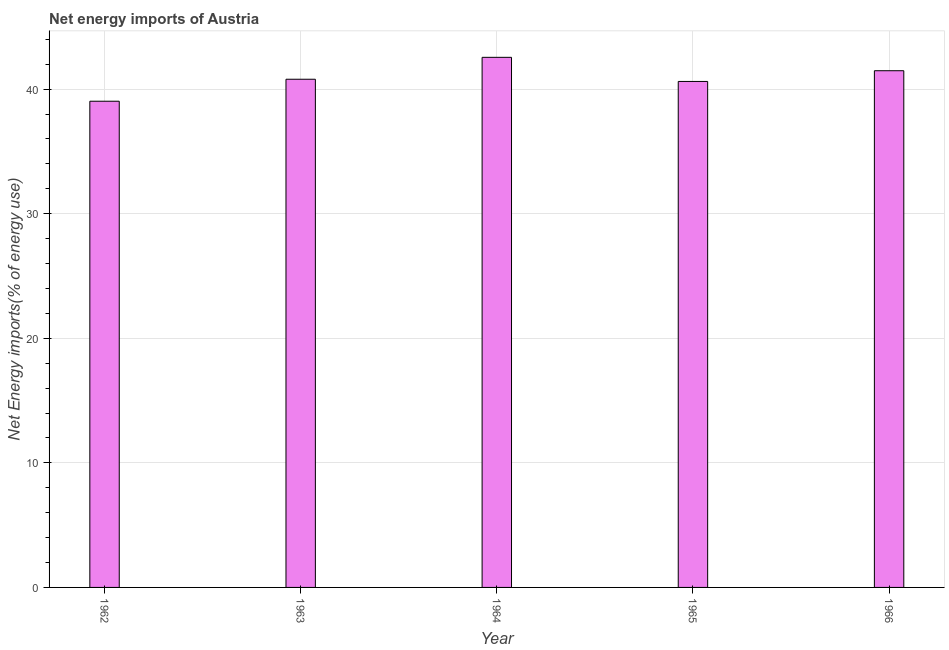What is the title of the graph?
Give a very brief answer. Net energy imports of Austria. What is the label or title of the Y-axis?
Keep it short and to the point. Net Energy imports(% of energy use). What is the energy imports in 1962?
Provide a short and direct response. 39.03. Across all years, what is the maximum energy imports?
Offer a terse response. 42.55. Across all years, what is the minimum energy imports?
Make the answer very short. 39.03. In which year was the energy imports maximum?
Make the answer very short. 1964. In which year was the energy imports minimum?
Your answer should be very brief. 1962. What is the sum of the energy imports?
Your answer should be very brief. 204.48. What is the difference between the energy imports in 1963 and 1965?
Your answer should be very brief. 0.18. What is the average energy imports per year?
Provide a short and direct response. 40.9. What is the median energy imports?
Offer a very short reply. 40.8. In how many years, is the energy imports greater than 36 %?
Your answer should be compact. 5. What is the ratio of the energy imports in 1964 to that in 1966?
Ensure brevity in your answer.  1.03. Is the energy imports in 1962 less than that in 1963?
Provide a short and direct response. Yes. What is the difference between the highest and the second highest energy imports?
Provide a succinct answer. 1.08. Is the sum of the energy imports in 1963 and 1966 greater than the maximum energy imports across all years?
Your response must be concise. Yes. What is the difference between the highest and the lowest energy imports?
Your response must be concise. 3.52. In how many years, is the energy imports greater than the average energy imports taken over all years?
Provide a succinct answer. 2. How many bars are there?
Offer a terse response. 5. Are the values on the major ticks of Y-axis written in scientific E-notation?
Provide a short and direct response. No. What is the Net Energy imports(% of energy use) in 1962?
Keep it short and to the point. 39.03. What is the Net Energy imports(% of energy use) of 1963?
Provide a succinct answer. 40.8. What is the Net Energy imports(% of energy use) in 1964?
Ensure brevity in your answer.  42.55. What is the Net Energy imports(% of energy use) in 1965?
Provide a succinct answer. 40.62. What is the Net Energy imports(% of energy use) in 1966?
Your response must be concise. 41.48. What is the difference between the Net Energy imports(% of energy use) in 1962 and 1963?
Your response must be concise. -1.77. What is the difference between the Net Energy imports(% of energy use) in 1962 and 1964?
Ensure brevity in your answer.  -3.52. What is the difference between the Net Energy imports(% of energy use) in 1962 and 1965?
Your response must be concise. -1.59. What is the difference between the Net Energy imports(% of energy use) in 1962 and 1966?
Give a very brief answer. -2.45. What is the difference between the Net Energy imports(% of energy use) in 1963 and 1964?
Offer a terse response. -1.76. What is the difference between the Net Energy imports(% of energy use) in 1963 and 1965?
Offer a terse response. 0.18. What is the difference between the Net Energy imports(% of energy use) in 1963 and 1966?
Give a very brief answer. -0.68. What is the difference between the Net Energy imports(% of energy use) in 1964 and 1965?
Give a very brief answer. 1.94. What is the difference between the Net Energy imports(% of energy use) in 1964 and 1966?
Provide a succinct answer. 1.08. What is the difference between the Net Energy imports(% of energy use) in 1965 and 1966?
Offer a very short reply. -0.86. What is the ratio of the Net Energy imports(% of energy use) in 1962 to that in 1963?
Provide a succinct answer. 0.96. What is the ratio of the Net Energy imports(% of energy use) in 1962 to that in 1964?
Provide a succinct answer. 0.92. What is the ratio of the Net Energy imports(% of energy use) in 1962 to that in 1966?
Give a very brief answer. 0.94. What is the ratio of the Net Energy imports(% of energy use) in 1963 to that in 1965?
Offer a terse response. 1. What is the ratio of the Net Energy imports(% of energy use) in 1964 to that in 1965?
Your answer should be very brief. 1.05. 